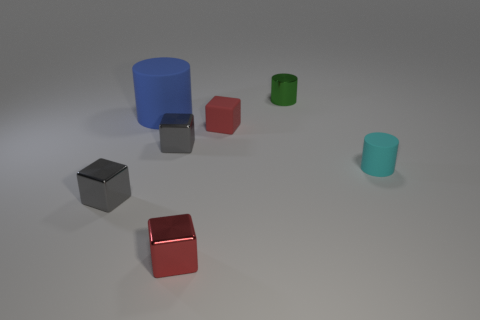There is a small shiny thing that is the same shape as the big rubber thing; what is its color?
Keep it short and to the point. Green. What is the color of the small object to the left of the cylinder to the left of the tiny green shiny object?
Offer a terse response. Gray. The tiny red matte object is what shape?
Provide a short and direct response. Cube. There is a rubber thing that is both in front of the large blue rubber object and to the left of the green shiny cylinder; what is its shape?
Give a very brief answer. Cube. There is a small cube that is the same material as the cyan thing; what color is it?
Offer a very short reply. Red. There is a tiny red object that is behind the gray metallic object in front of the rubber thing in front of the small red matte object; what is its shape?
Provide a short and direct response. Cube. What size is the shiny cylinder?
Offer a very short reply. Small. What is the shape of the red thing that is made of the same material as the green thing?
Your answer should be compact. Cube. Is the number of small things that are to the right of the tiny metal cylinder less than the number of gray balls?
Your answer should be compact. No. The metallic thing that is behind the blue object is what color?
Your answer should be very brief. Green. 